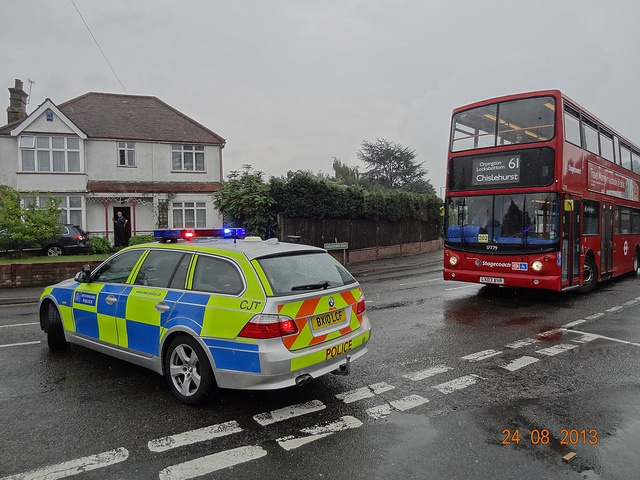Describe the objects in this image and their specific colors. I can see car in darkgray, gray, black, and olive tones, bus in darkgray, black, gray, and maroon tones, car in darkgray, gray, black, and darkgreen tones, people in darkgray, gray, and black tones, and people in darkgray, black, and gray tones in this image. 